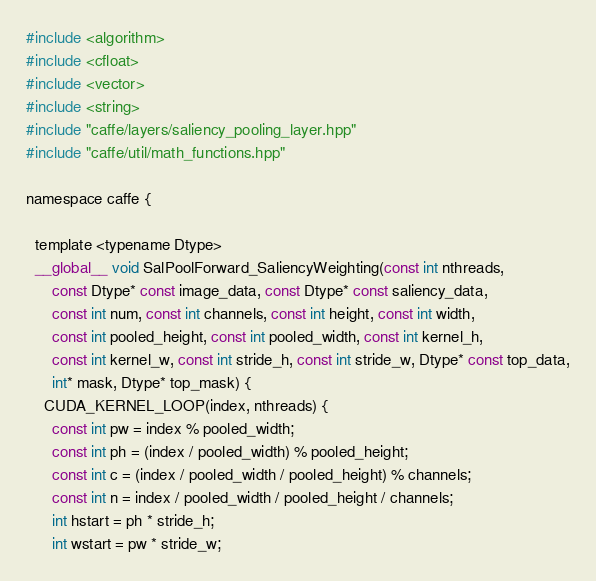Convert code to text. <code><loc_0><loc_0><loc_500><loc_500><_Cuda_>#include <algorithm>
#include <cfloat>
#include <vector>
#include <string>
#include "caffe/layers/saliency_pooling_layer.hpp"
#include "caffe/util/math_functions.hpp"

namespace caffe {

  template <typename Dtype>
  __global__ void SalPoolForward_SaliencyWeighting(const int nthreads,
      const Dtype* const image_data, const Dtype* const saliency_data,
      const int num, const int channels, const int height, const int width,
      const int pooled_height, const int pooled_width, const int kernel_h,
      const int kernel_w, const int stride_h, const int stride_w, Dtype* const top_data,
      int* mask, Dtype* top_mask) {
    CUDA_KERNEL_LOOP(index, nthreads) {
      const int pw = index % pooled_width;
      const int ph = (index / pooled_width) % pooled_height;
      const int c = (index / pooled_width / pooled_height) % channels;
      const int n = index / pooled_width / pooled_height / channels;
      int hstart = ph * stride_h;
      int wstart = pw * stride_w;</code> 